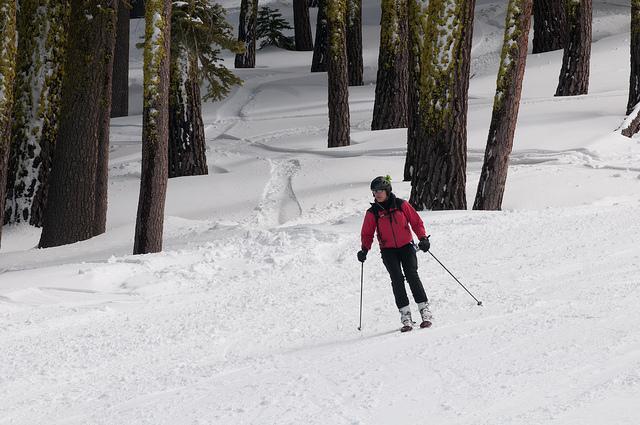Is it warm outside in this photo?
Answer briefly. No. What is the man doing?
Be succinct. Skiing. Is there any vegetation in the photo?
Keep it brief. No. 